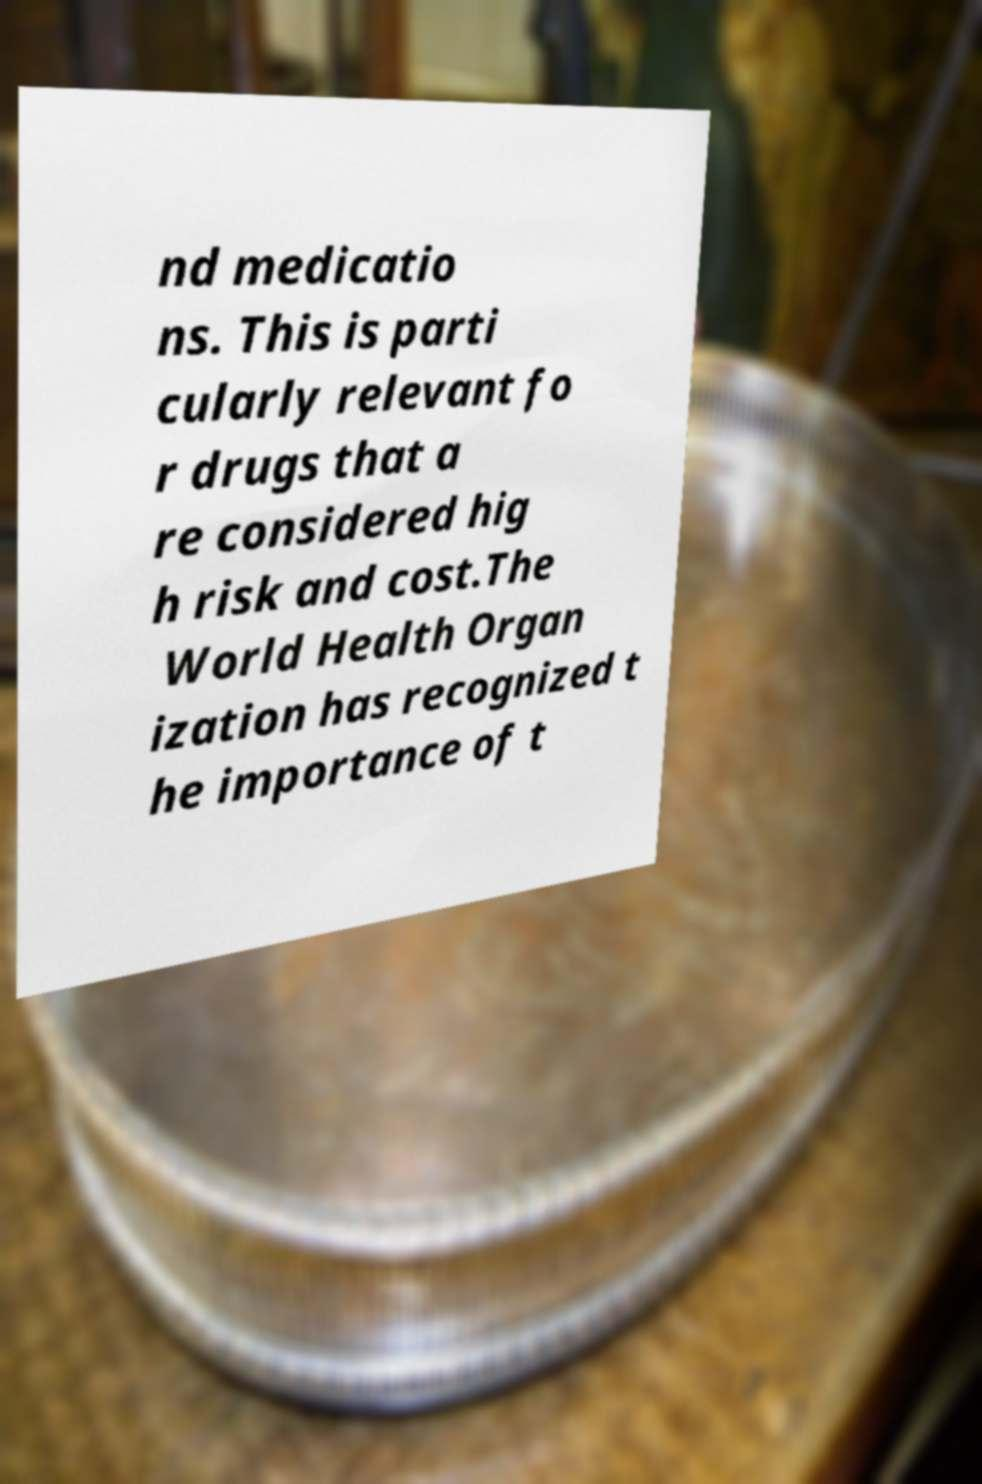Can you read and provide the text displayed in the image?This photo seems to have some interesting text. Can you extract and type it out for me? nd medicatio ns. This is parti cularly relevant fo r drugs that a re considered hig h risk and cost.The World Health Organ ization has recognized t he importance of t 